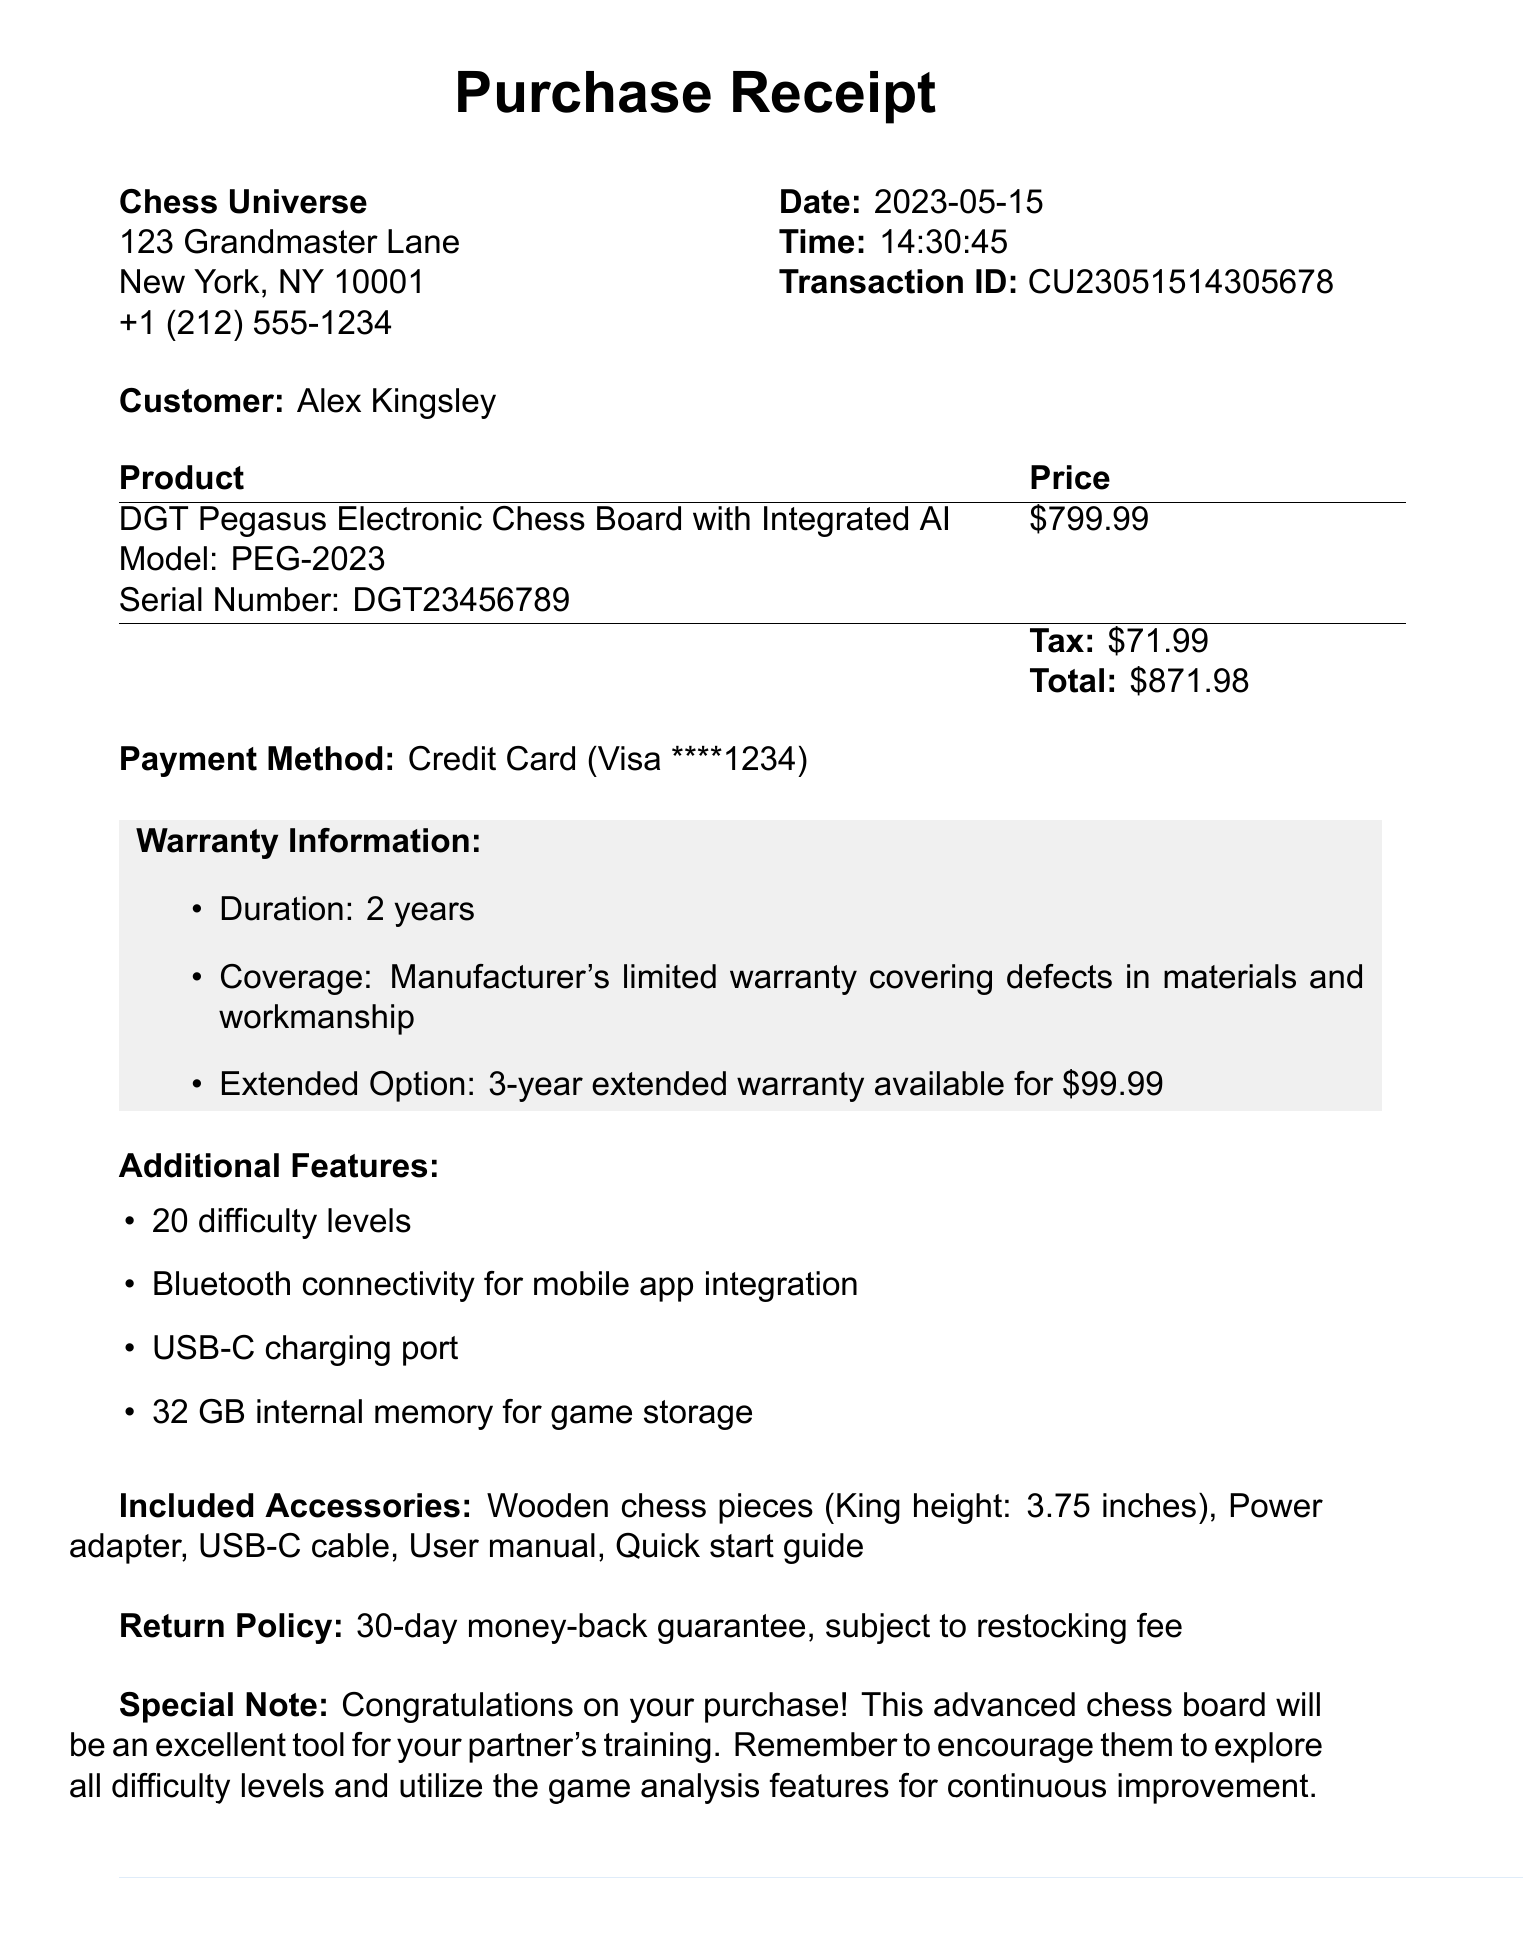What is the name of the product? The name of the product is stated clearly in the document as "DGT Pegasus Electronic Chess Board with Integrated AI."
Answer: DGT Pegasus Electronic Chess Board with Integrated AI What is the total price of the chess board? The total price is indicated in the price section of the document and includes the base price and tax.
Answer: 871.98 Who was the sales associate? The document specifies that the sales associate who helped with the purchase is Emma Bishop.
Answer: Emma Bishop What is the warranty duration? The warranty section clearly mentions that the duration of the warranty is 2 years.
Answer: 2 years What is the email for customer support? The document provides a specific email address for support inquiries.
Answer: support@chessuniverse.com How many difficulty levels does the chess board have? This information is included in the additional features section of the document.
Answer: 20 difficulty levels What is the return policy? The document outlines that there is a 30-day money-back guarantee, which is part of the return policy stated.
Answer: 30-day money-back guarantee What is the extended warranty option cost? The warranty section indicates the cost for the extended warranty option.
Answer: 99.99 What is the transaction ID? The document mentions the transaction ID related to this purchase for reference.
Answer: CU23051514305678 